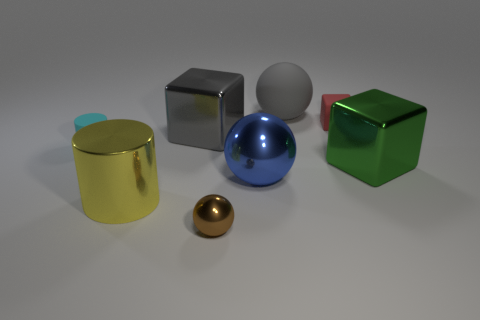Subtract all large balls. How many balls are left? 1 Subtract all brown balls. How many balls are left? 2 Subtract all balls. How many objects are left? 5 Add 2 tiny red things. How many objects exist? 10 Subtract 1 cubes. How many cubes are left? 2 Add 2 big gray balls. How many big gray balls are left? 3 Add 7 large yellow shiny cylinders. How many large yellow shiny cylinders exist? 8 Subtract 0 red cylinders. How many objects are left? 8 Subtract all purple cylinders. Subtract all yellow balls. How many cylinders are left? 2 Subtract all blue matte things. Subtract all cyan things. How many objects are left? 7 